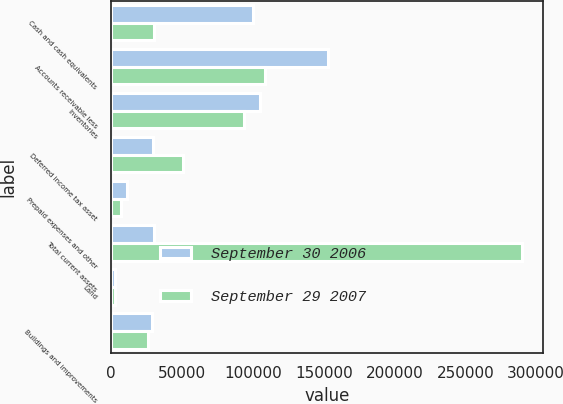<chart> <loc_0><loc_0><loc_500><loc_500><stacked_bar_chart><ecel><fcel>Cash and cash equivalents<fcel>Accounts receivable less<fcel>Inventories<fcel>Deferred income tax asset<fcel>Prepaid expenses and other<fcel>Total current assets<fcel>Land<fcel>Buildings and improvements<nl><fcel>September 30 2006<fcel>100403<fcel>152743<fcel>105289<fcel>29356<fcel>11389<fcel>29923<fcel>2710<fcel>28577<nl><fcel>September 29 2007<fcel>29923<fcel>108566<fcel>93477<fcel>50944<fcel>7112<fcel>290022<fcel>2695<fcel>25699<nl></chart> 